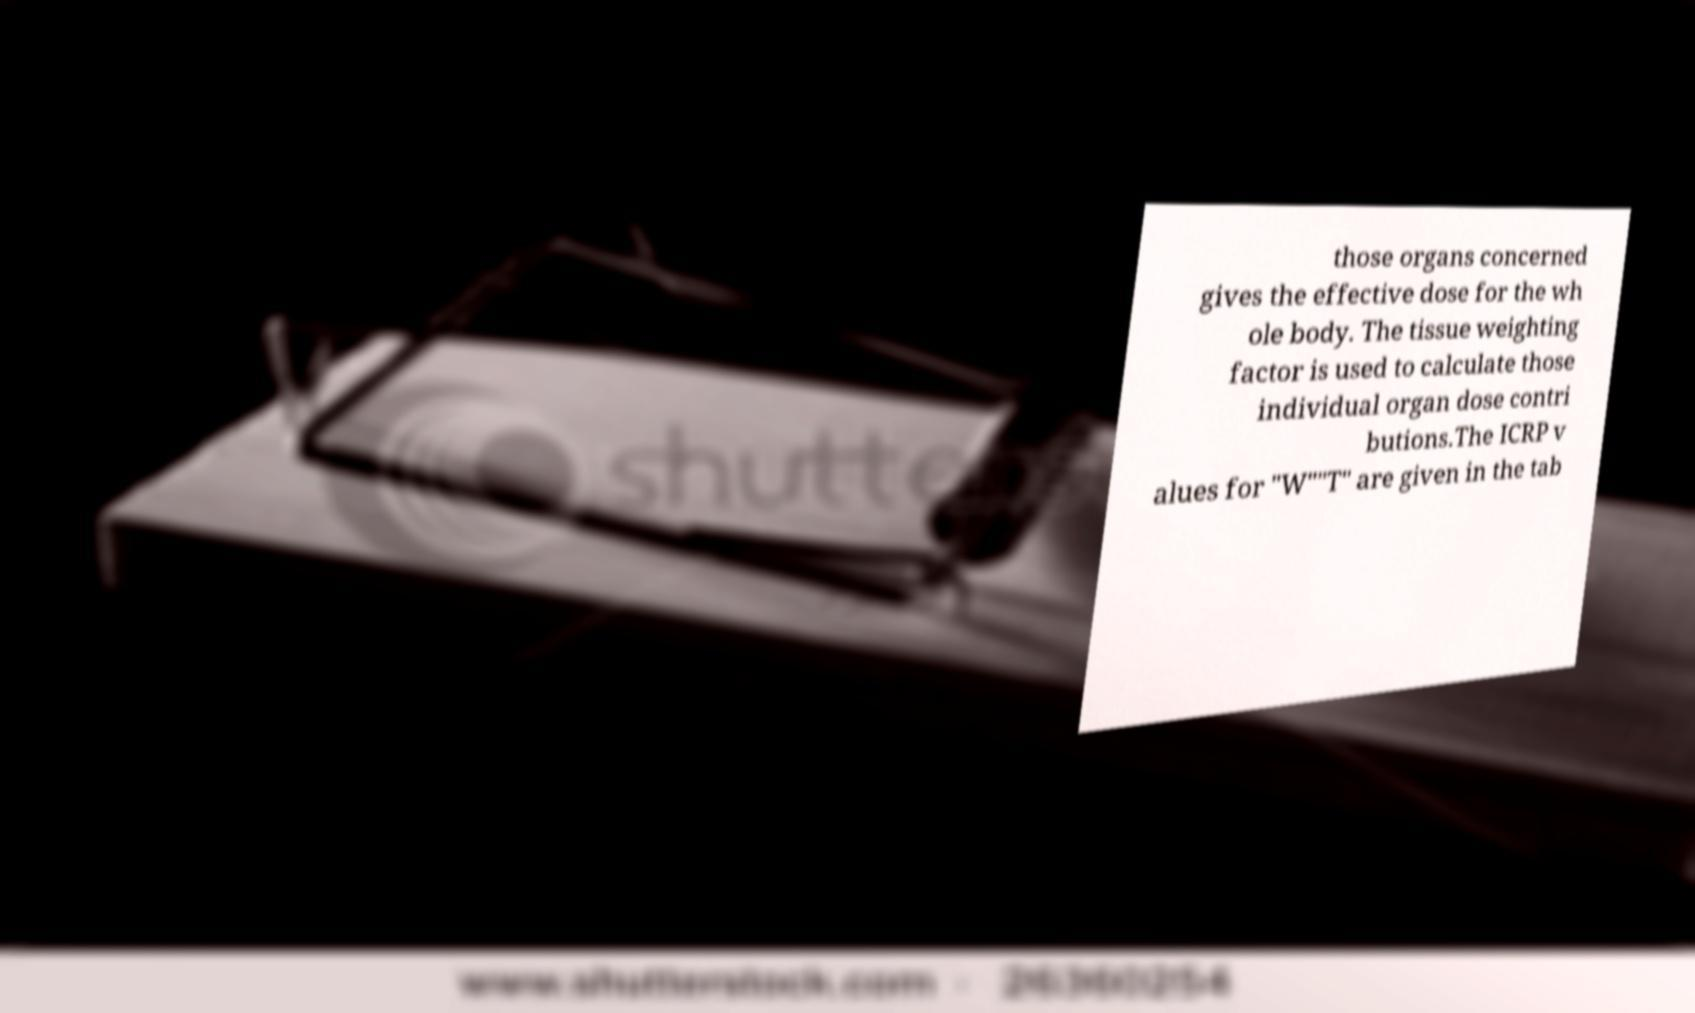Please identify and transcribe the text found in this image. those organs concerned gives the effective dose for the wh ole body. The tissue weighting factor is used to calculate those individual organ dose contri butions.The ICRP v alues for "W""T" are given in the tab 